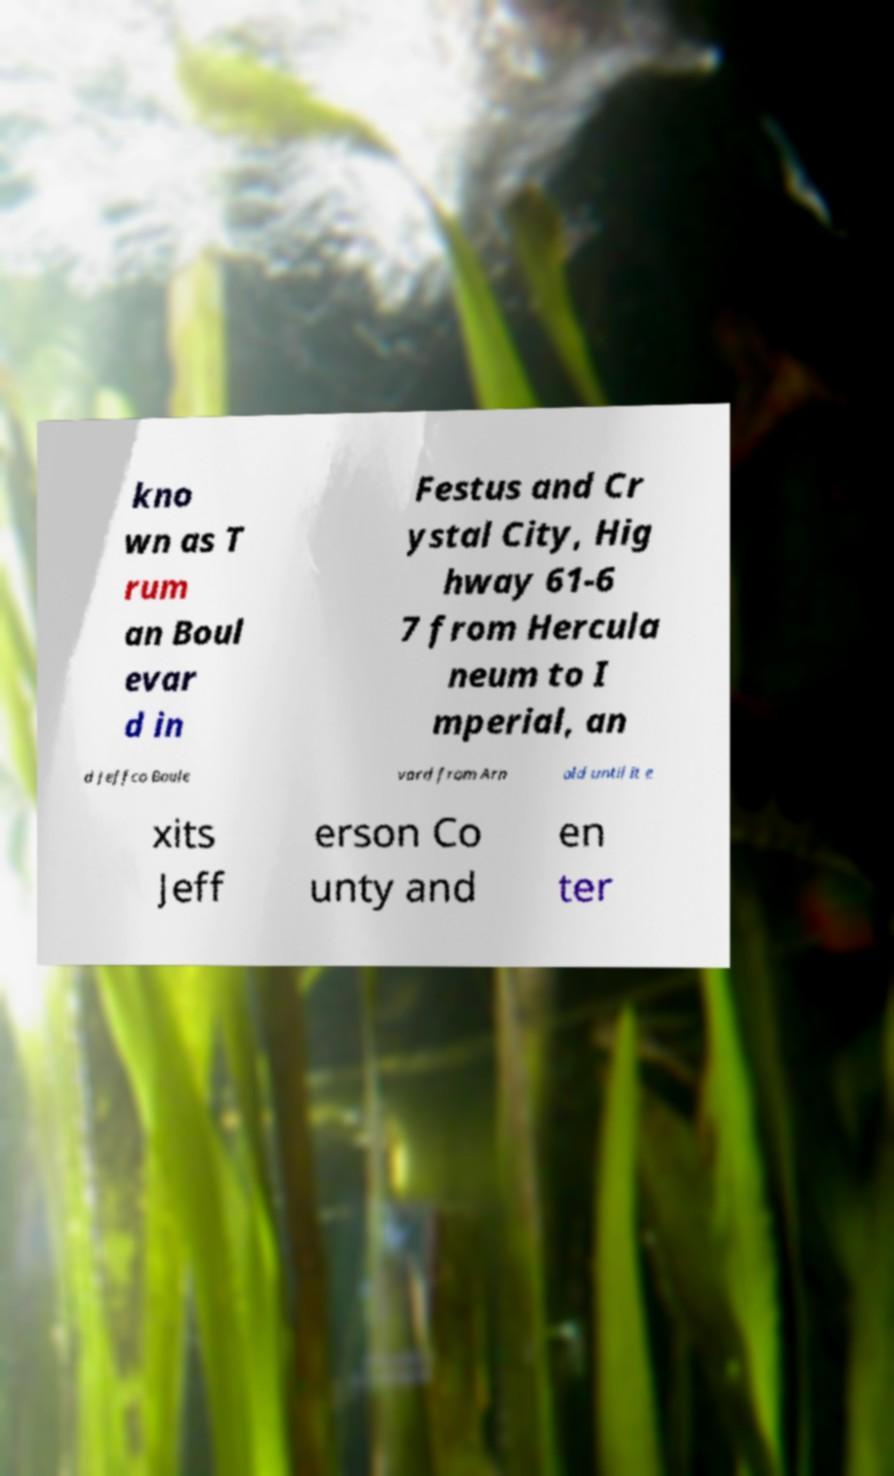Please read and relay the text visible in this image. What does it say? kno wn as T rum an Boul evar d in Festus and Cr ystal City, Hig hway 61-6 7 from Hercula neum to I mperial, an d Jeffco Boule vard from Arn old until it e xits Jeff erson Co unty and en ter 